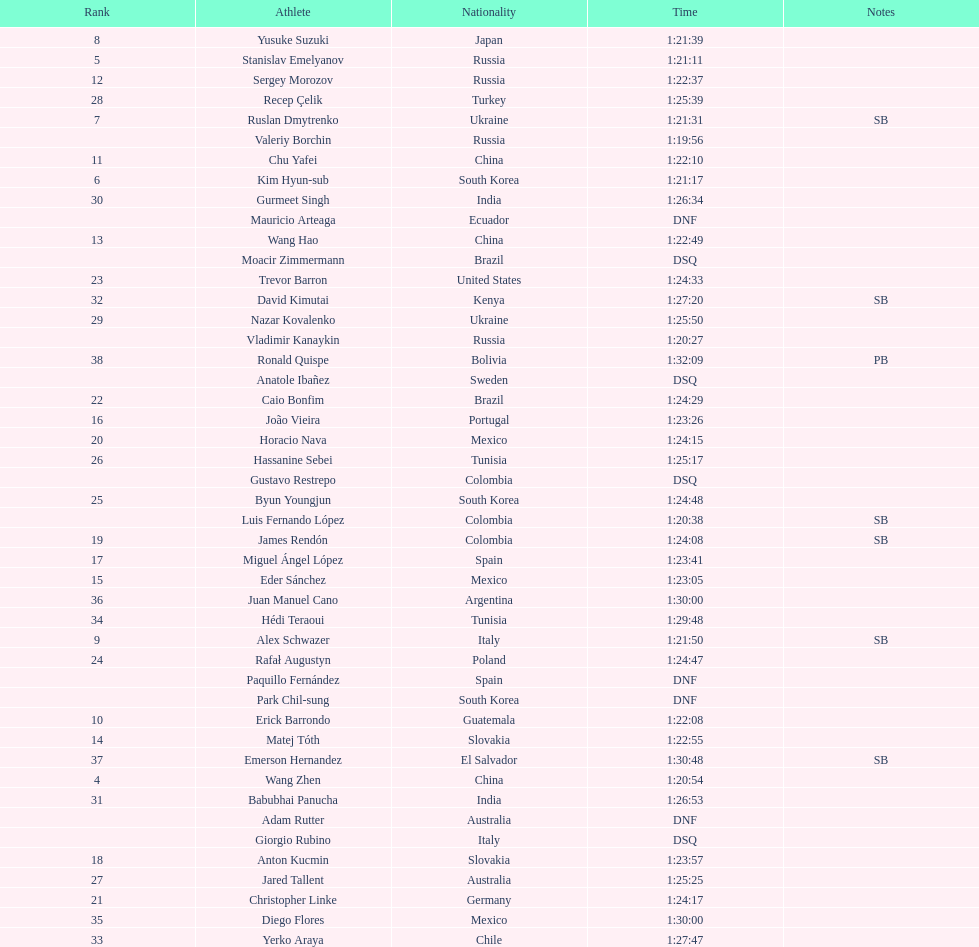Which chinese athlete had the fastest time? Wang Zhen. 